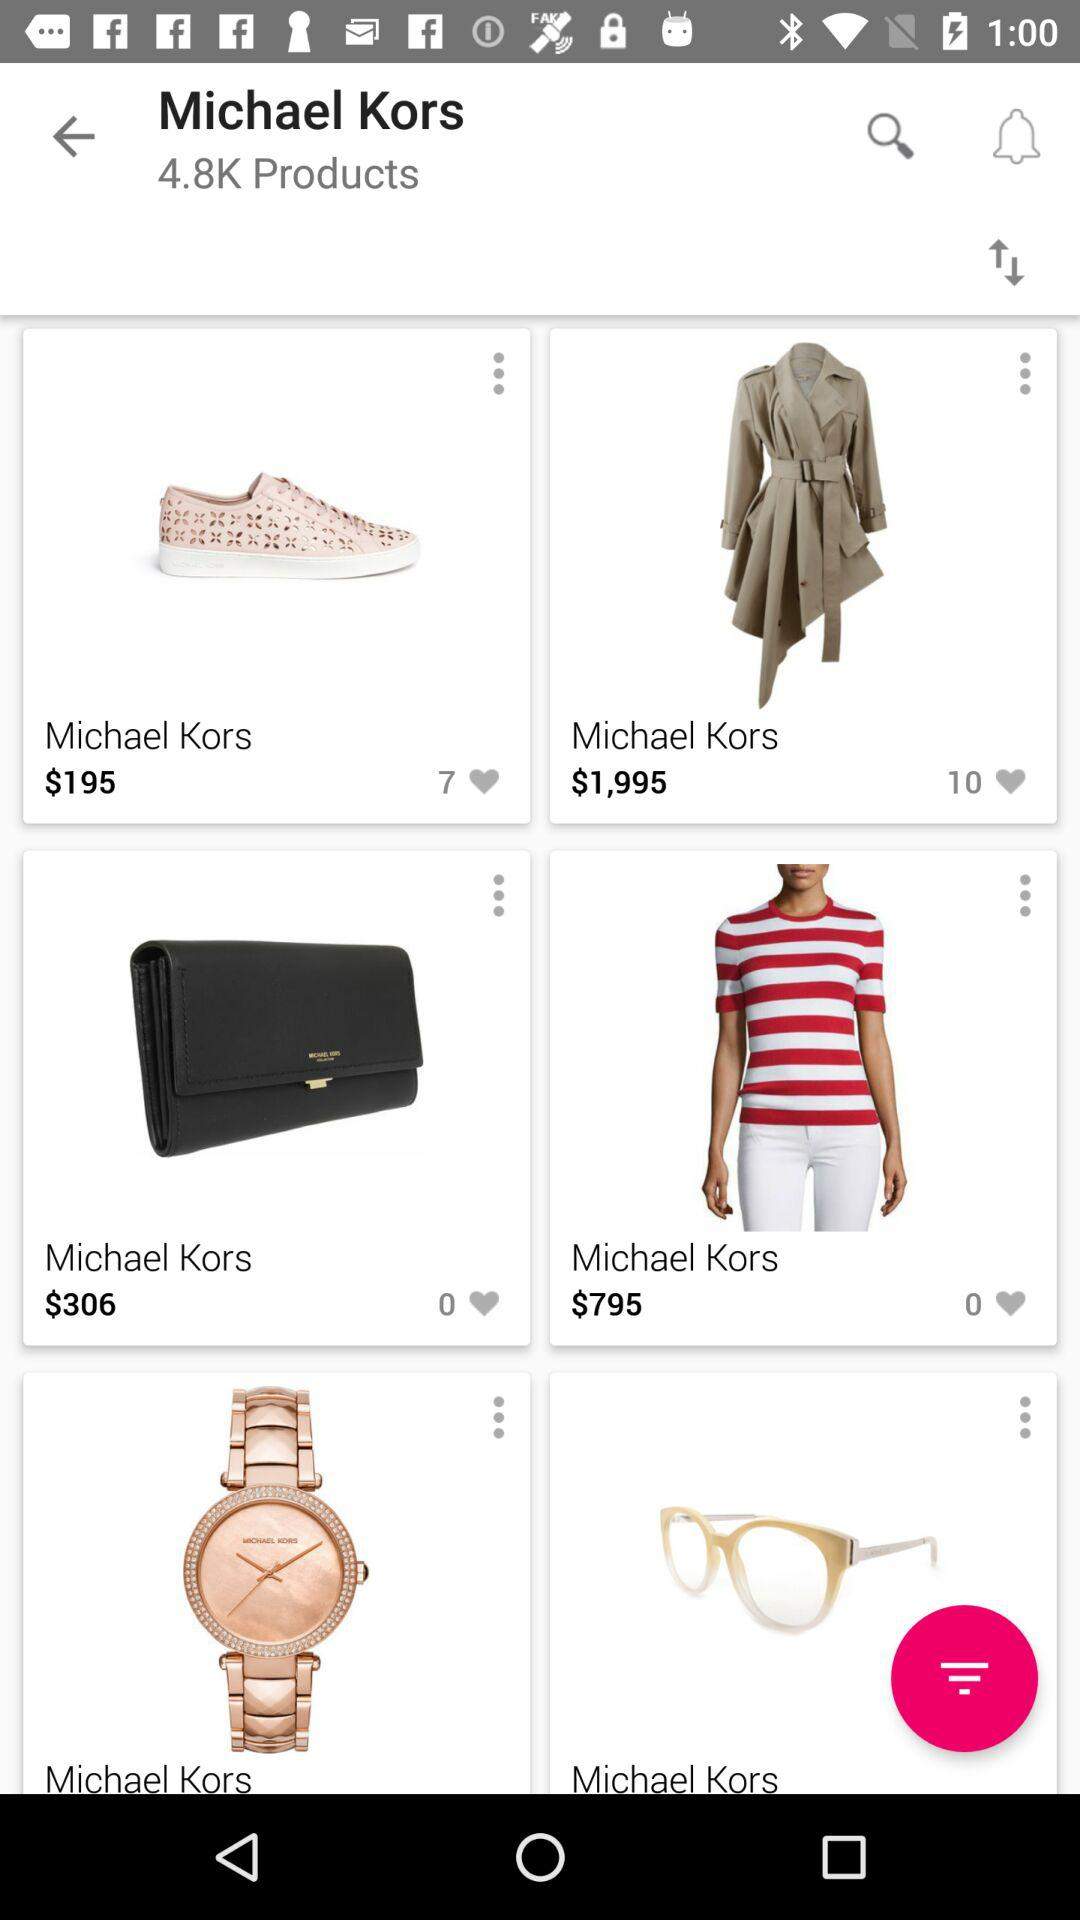How many total products are there by Michael Kors? There are a total of 4.8K products. 